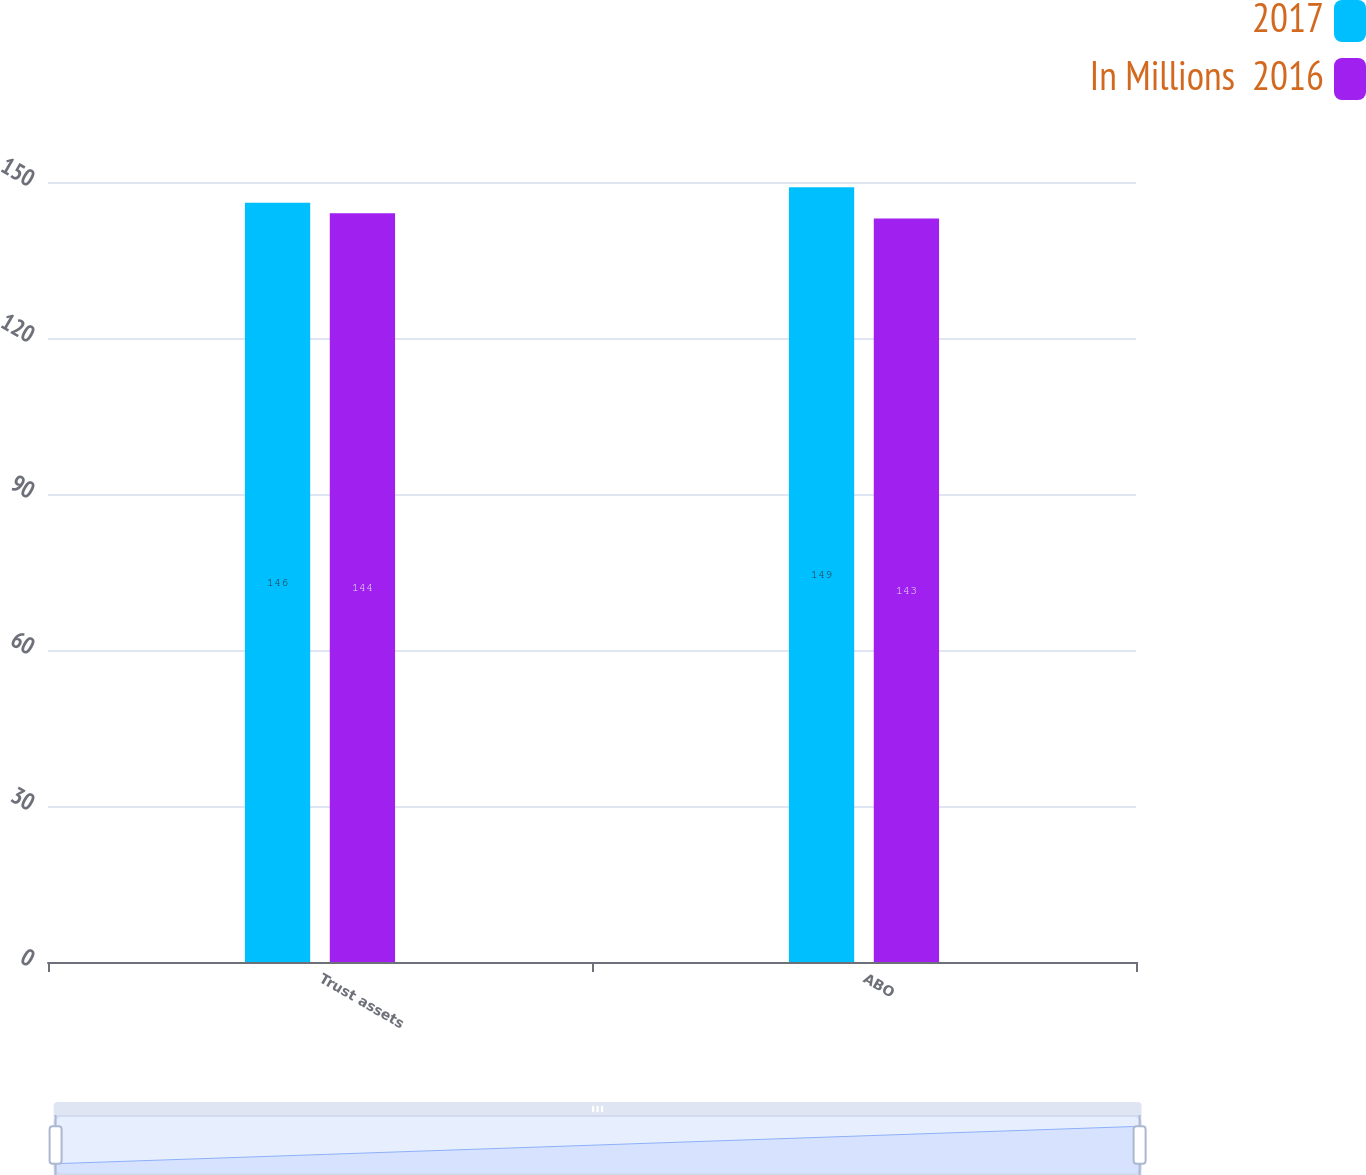Convert chart. <chart><loc_0><loc_0><loc_500><loc_500><stacked_bar_chart><ecel><fcel>Trust assets<fcel>ABO<nl><fcel>2017<fcel>146<fcel>149<nl><fcel>In Millions  2016<fcel>144<fcel>143<nl></chart> 